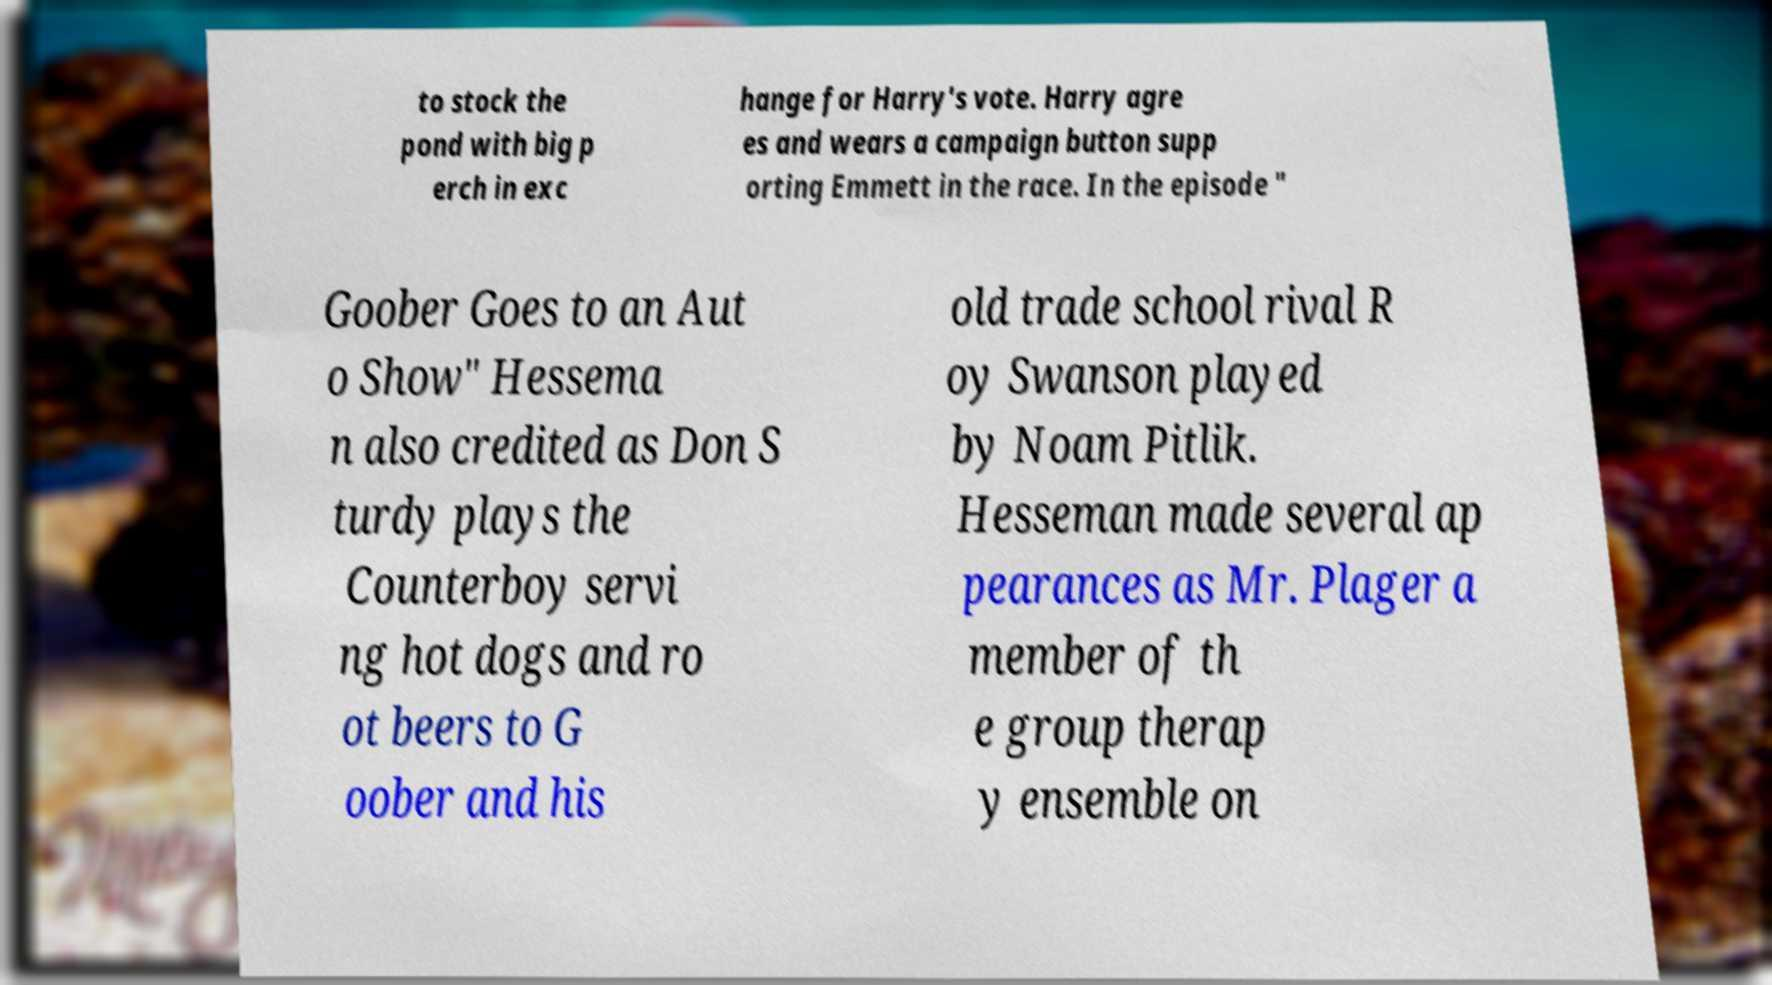Can you accurately transcribe the text from the provided image for me? to stock the pond with big p erch in exc hange for Harry's vote. Harry agre es and wears a campaign button supp orting Emmett in the race. In the episode " Goober Goes to an Aut o Show" Hessema n also credited as Don S turdy plays the Counterboy servi ng hot dogs and ro ot beers to G oober and his old trade school rival R oy Swanson played by Noam Pitlik. Hesseman made several ap pearances as Mr. Plager a member of th e group therap y ensemble on 